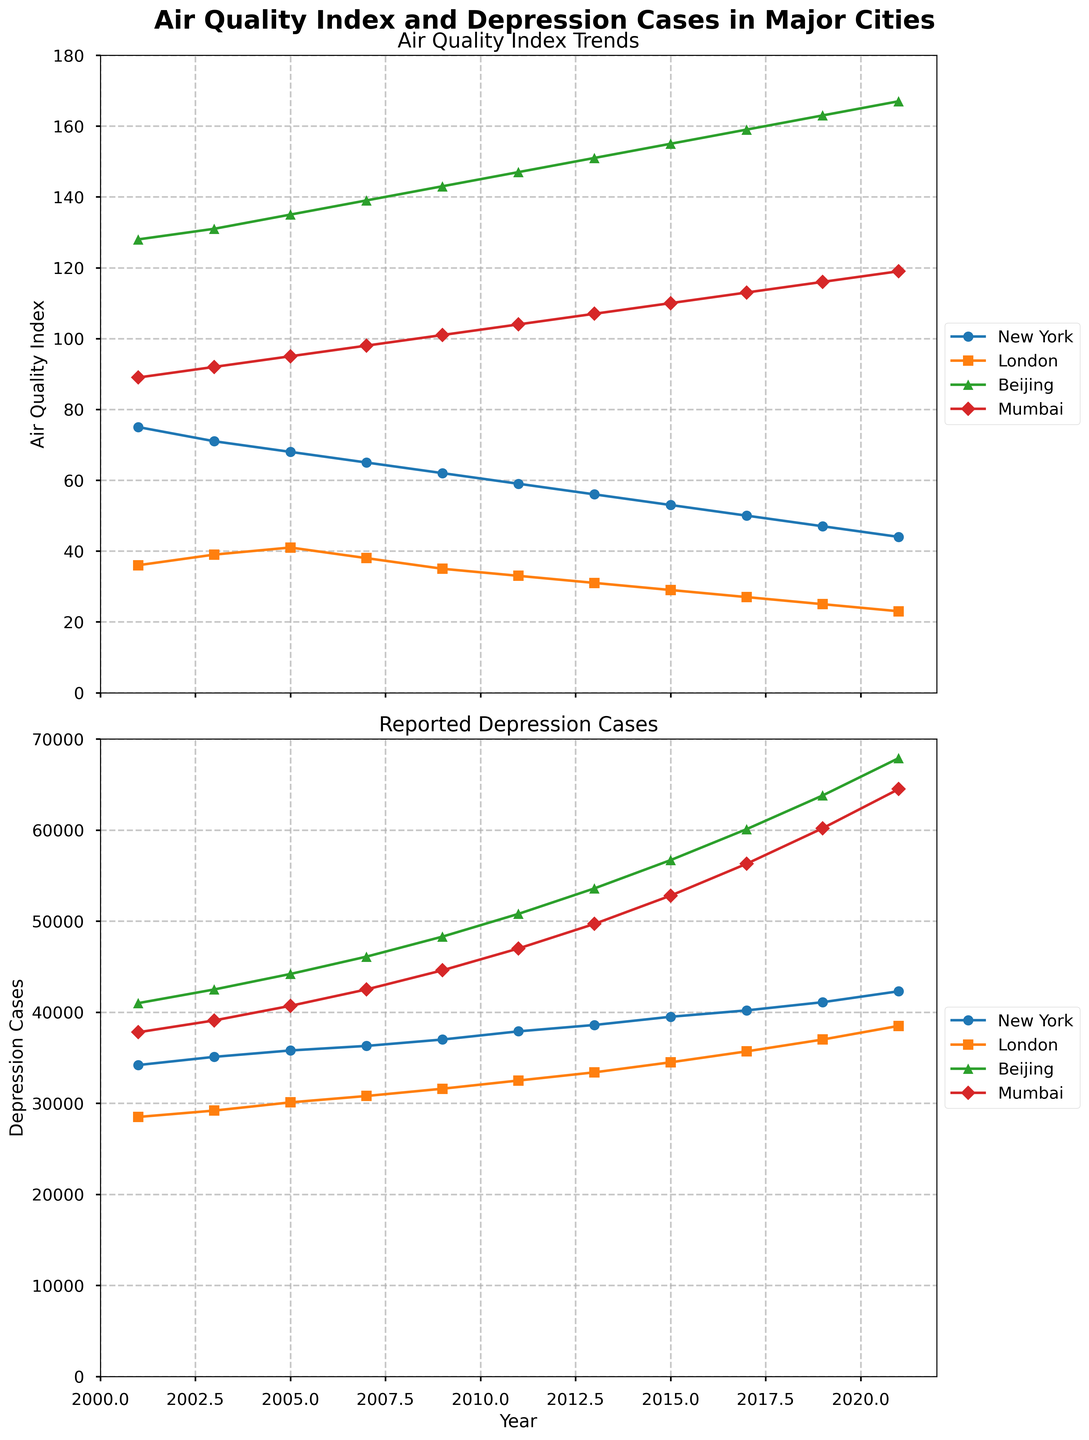Which city shows the greatest increase in depression cases over the 20-year period? To find the city with the greatest increase in depression cases, we must calculate the difference between the number of depression cases in 2021 and 2001 for each city. For New York, the increase is 42300 - 34200 = 8100. For London, it is 38500 - 28500 = 10000. For Beijing, it is 67900 - 41000 = 26900. For Mumbai, it is 64500 - 37800 = 26700. Beijing has the greatest increase at 26900.
Answer: Beijing How does the AQI trend in New York compare with London over the years? To compare the AQI trends, observe the general direction of the AQI lines for New York and London. Both cities show a decreasing trend, but the AQI is consistently higher in New York than in London throughout the years.
Answer: Decreasing but higher in New York In which year did Mumbai have its highest reported depression cases? The highest reported depression cases for Mumbai occur where the line reaches its peak. In the line chart for Mumbai, the peak in depression cases is at 2021 with 64500 cases.
Answer: 2021 What is the average AQI of Beijing over the 20-year period? To calculate the average AQI for Beijing, sum up all the AQI values from 2001 to 2021 and divide by the number of years (11): (128 + 131 + 135 + 139 + 143 + 147 + 151 + 155 + 159 + 163 + 167) / 11 = 151.09.
Answer: 151.09 Which city shows the smallest decrease in AQI from 2001 to 2021? Calculate the decrease in AQI for each city by subtracting the AQI value in 2021 from that in 2001. New York: 75 - 44 = 31, London: 36 - 23 = 13, Beijing: 167 - 128 = 39, Mumbai: 119 - 89 = 30. London shows the smallest decrease with 13.
Answer: London How does the number of depression cases in Beijing in 2009 compare to those in Mumbai in the same year? Look at the number of depression cases in 2009 for both cities. Beijing has 48300 cases, and Mumbai has 44600 cases. Beijing has more depression cases than Mumbai in 2009.
Answer: Beijing has more What is the trend observed for the AQI in all cities over the years? Observe the AQI trends for all cities. For New York, London, and Mumbai, the AQI decreases over the years. For Beijing, however, the AQI increases over the same period.
Answer: Decreasing in New York, London, Mumbai; increasing in Beijing Calculate the total number of depression cases reported in New York, London, Beijing, and Mumbai in the year 2019. Sum the number of depression cases in 2019 for all cities: 41100 (New York) + 37000 (London) + 63800 (Beijing) + 60200 (Mumbai) = 202100.
Answer: 202100 Which city experienced the most significant decrease in AQI from 2001 to 2021? Calculate the AQI decrease for each city as follows: New York: 75 - 44 = 31, London: 36 - 23 = 13, Beijing: 167 - 128 = 39, Mumbai: 119 - 89 = 30. Beijing experienced the most significant decrease of 39.
Answer: Beijing 